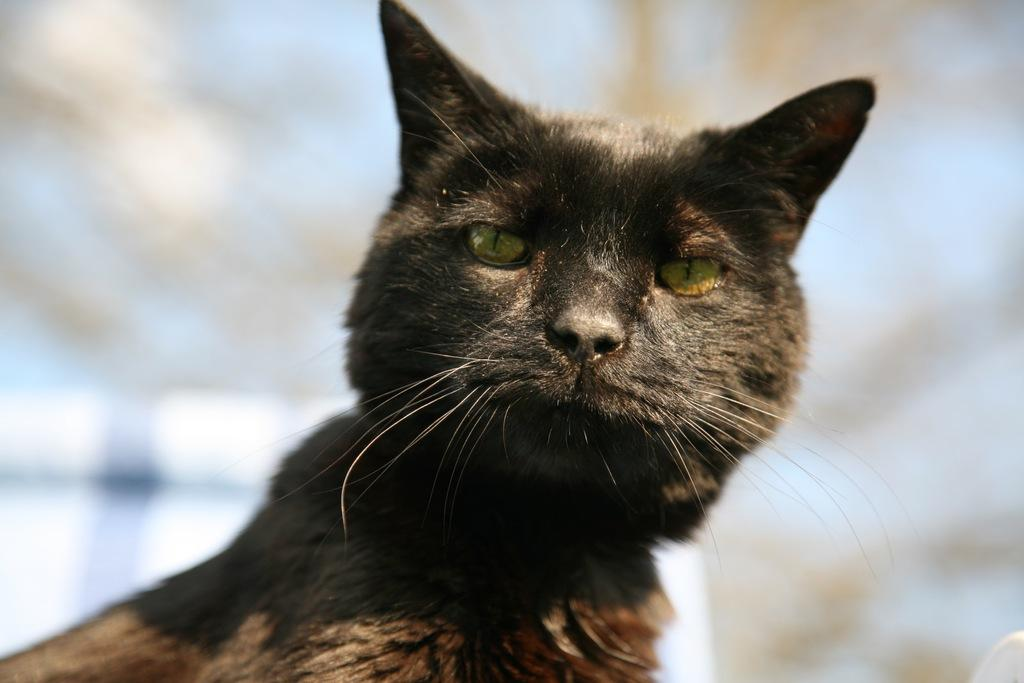What type of animal is present in the image? There is a cat in the image. What type of comb is being used to distribute the event in the image? There is no comb, distribution, or event present in the image; it only features a cat. 